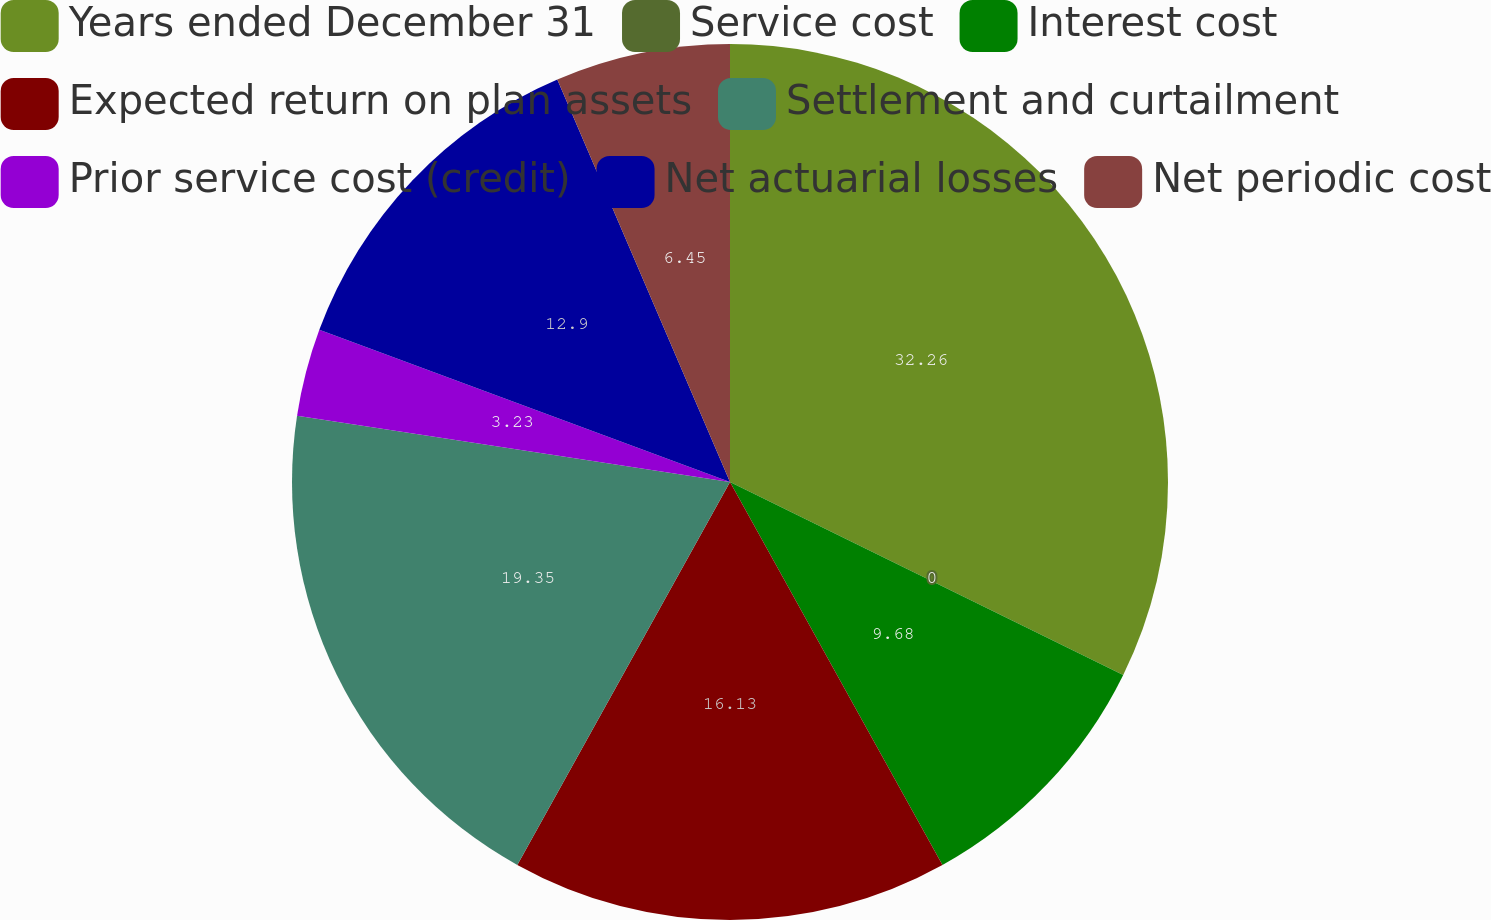<chart> <loc_0><loc_0><loc_500><loc_500><pie_chart><fcel>Years ended December 31<fcel>Service cost<fcel>Interest cost<fcel>Expected return on plan assets<fcel>Settlement and curtailment<fcel>Prior service cost (credit)<fcel>Net actuarial losses<fcel>Net periodic cost<nl><fcel>32.26%<fcel>0.0%<fcel>9.68%<fcel>16.13%<fcel>19.35%<fcel>3.23%<fcel>12.9%<fcel>6.45%<nl></chart> 